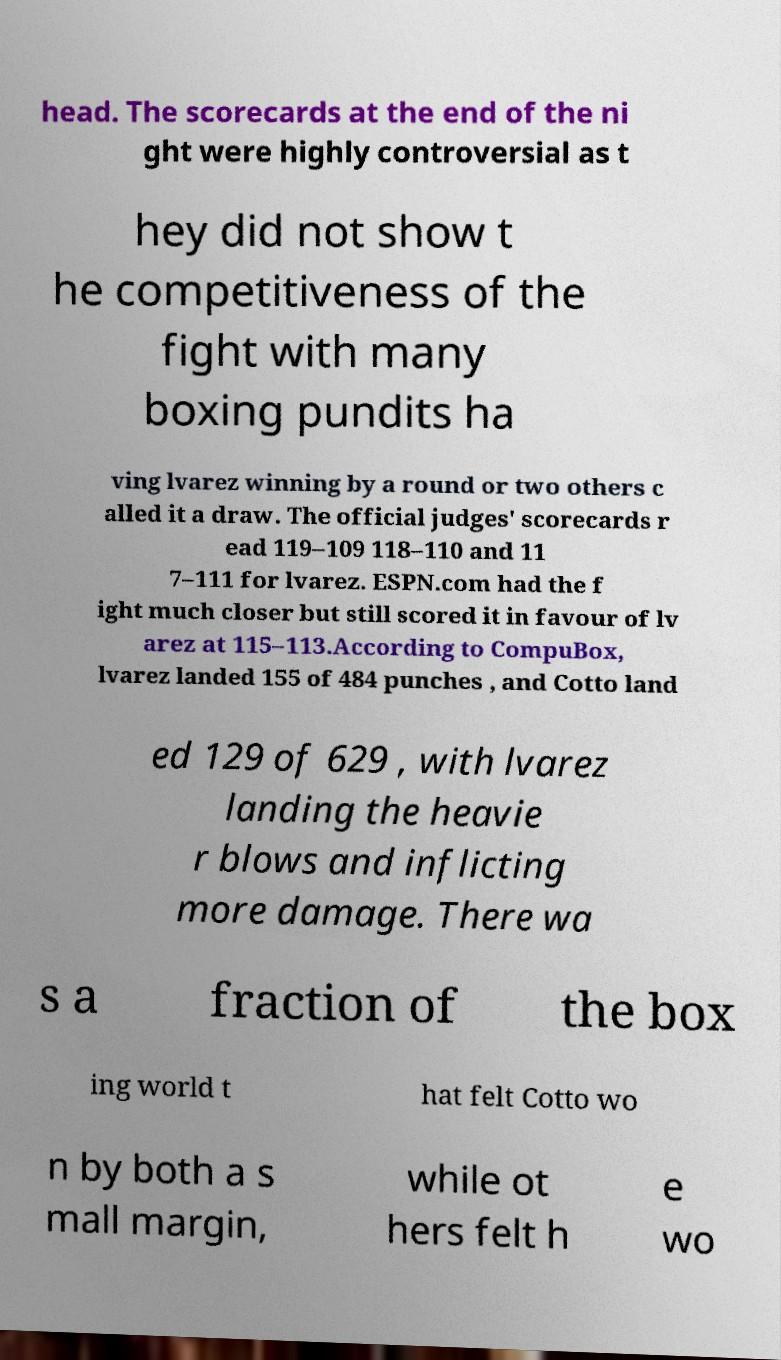Could you assist in decoding the text presented in this image and type it out clearly? head. The scorecards at the end of the ni ght were highly controversial as t hey did not show t he competitiveness of the fight with many boxing pundits ha ving lvarez winning by a round or two others c alled it a draw. The official judges' scorecards r ead 119–109 118–110 and 11 7–111 for lvarez. ESPN.com had the f ight much closer but still scored it in favour of lv arez at 115–113.According to CompuBox, lvarez landed 155 of 484 punches , and Cotto land ed 129 of 629 , with lvarez landing the heavie r blows and inflicting more damage. There wa s a fraction of the box ing world t hat felt Cotto wo n by both a s mall margin, while ot hers felt h e wo 